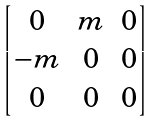Convert formula to latex. <formula><loc_0><loc_0><loc_500><loc_500>\begin{bmatrix} 0 & m & 0 \\ - m & 0 & 0 \\ 0 & 0 & 0 \\ \end{bmatrix}</formula> 